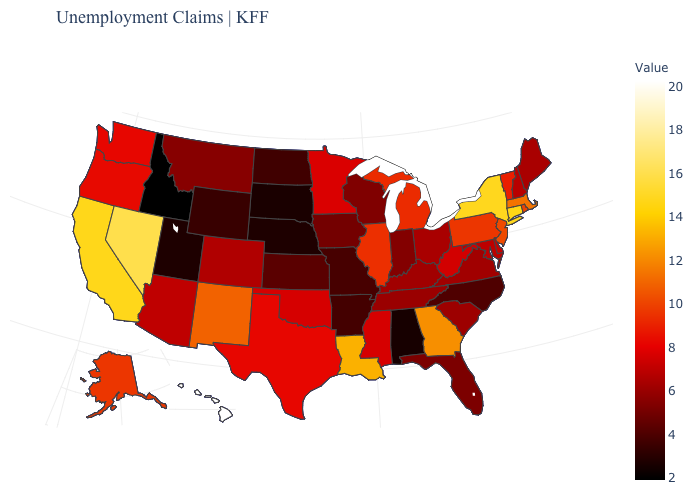Among the states that border Montana , does Wyoming have the highest value?
Quick response, please. No. Among the states that border Maryland , does Pennsylvania have the highest value?
Short answer required. Yes. Does New Hampshire have a lower value than Missouri?
Concise answer only. No. Does Hawaii have the highest value in the USA?
Write a very short answer. Yes. 